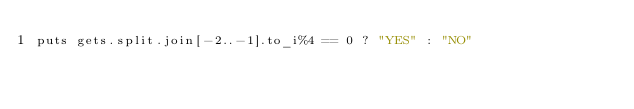Convert code to text. <code><loc_0><loc_0><loc_500><loc_500><_Ruby_>puts gets.split.join[-2..-1].to_i%4 == 0 ? "YES" : "NO"</code> 